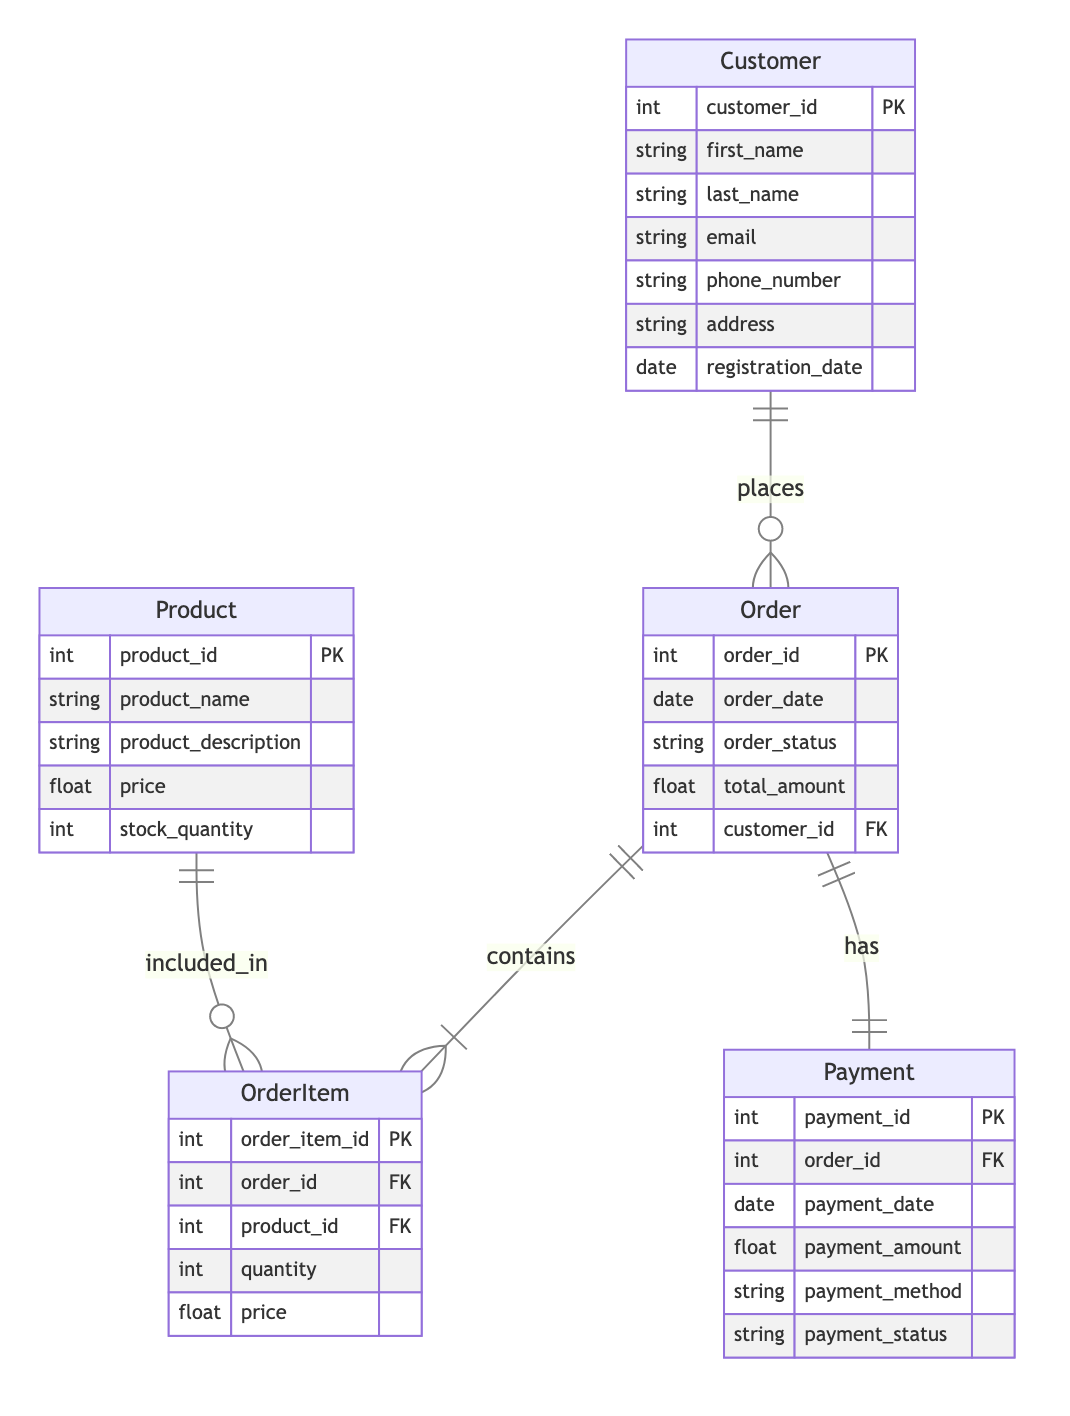What is the primary key of the Customer entity? The primary key for the Customer entity is defined as customer_id, indicating that this is the unique identifier for each customer record in the database.
Answer: customer_id How many attributes are in the Order entity? The Order entity contains five attributes: order_id, order_date, order_status, total_amount, and customer_id. This is directly observed from the attributes listed under the Order entity in the diagram.
Answer: 5 What type of relationship exists between Order and Payment? The relationship between Order and Payment is labeled as OneToOne, meaning that each order is associated with exactly one payment record, as indicated in the relationships section of the diagram.
Answer: OneToOne Which entity does OrderItem reference as a foreign key? The OrderItem entity has foreign keys referencing both Order and Product entities. This means that each order item is associated with a specific order and a specific product.
Answer: Order, Product How many products can be included in a single OrderItem? Each OrderItem can only reference one product, which is indicated by the foreign key product_id in the OrderItem entity. Therefore, an OrderItem is limited to a single product, though each product can appear in multiple OrderItems.
Answer: One What is the relationship type between Customer and Order? The relationship between Customer and Order is defined as OneToMany, which indicates that each customer can place multiple orders, but each order is linked to just one customer.
Answer: OneToMany What does the attribute 'payment_status' represent in the Payment entity? The attribute 'payment_status' in the Payment entity indicates the current status of the payment (e.g., completed, pending, failed), reflecting the outcome of a payment transaction related to an order.
Answer: Current payment status How many entities are in the diagram? There are five distinct entities in the diagram: Customer, Order, OrderItem, Product, and Payment. This count can be verified by reviewing the entities section of the diagram.
Answer: 5 What is the foreign key in the Order entity? The foreign key in the Order entity is customer_id, which establishes a link between the order and the customer who placed it. This allows for the identification of which customer an order belongs to.
Answer: customer_id 